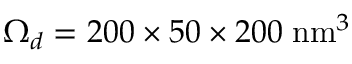Convert formula to latex. <formula><loc_0><loc_0><loc_500><loc_500>\Omega _ { d } = 2 0 0 \times 5 0 \times 2 0 0 \, n m ^ { 3 }</formula> 